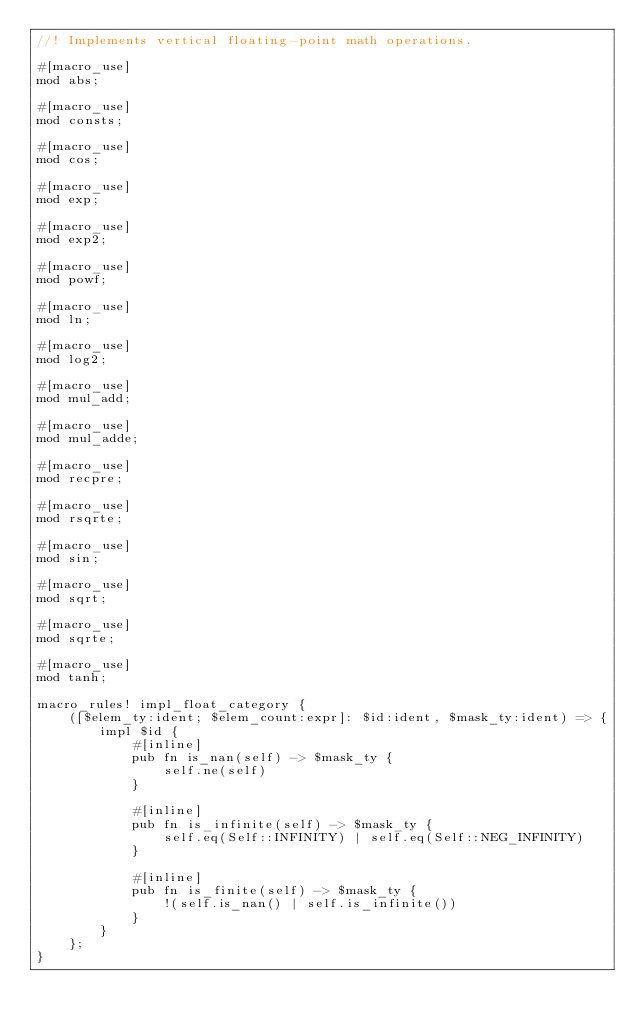Convert code to text. <code><loc_0><loc_0><loc_500><loc_500><_Rust_>//! Implements vertical floating-point math operations.

#[macro_use]
mod abs;

#[macro_use]
mod consts;

#[macro_use]
mod cos;

#[macro_use]
mod exp;

#[macro_use]
mod exp2;

#[macro_use]
mod powf;

#[macro_use]
mod ln;

#[macro_use]
mod log2;

#[macro_use]
mod mul_add;

#[macro_use]
mod mul_adde;

#[macro_use]
mod recpre;

#[macro_use]
mod rsqrte;

#[macro_use]
mod sin;

#[macro_use]
mod sqrt;

#[macro_use]
mod sqrte;

#[macro_use]
mod tanh;

macro_rules! impl_float_category {
    ([$elem_ty:ident; $elem_count:expr]: $id:ident, $mask_ty:ident) => {
        impl $id {
            #[inline]
            pub fn is_nan(self) -> $mask_ty {
                self.ne(self)
            }

            #[inline]
            pub fn is_infinite(self) -> $mask_ty {
                self.eq(Self::INFINITY) | self.eq(Self::NEG_INFINITY)
            }

            #[inline]
            pub fn is_finite(self) -> $mask_ty {
                !(self.is_nan() | self.is_infinite())
            }
        }
    };
}
</code> 